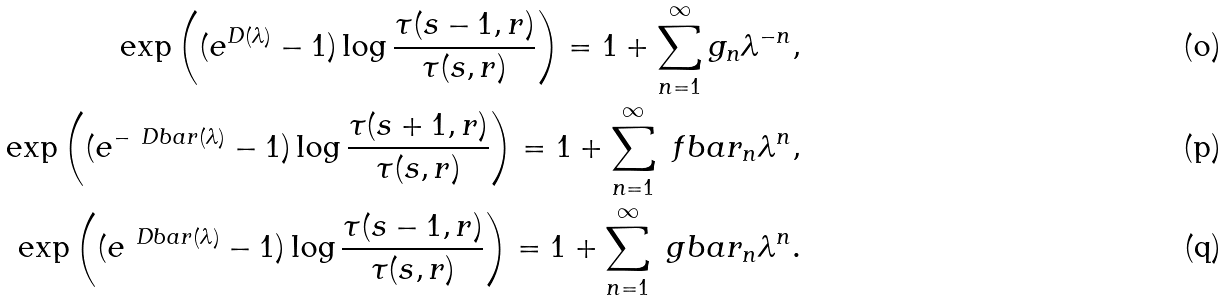<formula> <loc_0><loc_0><loc_500><loc_500>\exp \left ( ( e ^ { D ( \lambda ) } - 1 ) \log \frac { \tau ( s - 1 , r ) } { \tau ( s , r ) } \right ) = 1 + \sum _ { n = 1 } ^ { \infty } g _ { n } \lambda ^ { - n } , \\ \exp \left ( ( e ^ { - \ D b a r ( \lambda ) } - 1 ) \log \frac { \tau ( s + 1 , r ) } { \tau ( s , r ) } \right ) = 1 + \sum _ { n = 1 } ^ { \infty } \ f b a r _ { n } \lambda ^ { n } , \\ \exp \left ( ( e ^ { \ D b a r ( \lambda ) } - 1 ) \log \frac { \tau ( s - 1 , r ) } { \tau ( s , r ) } \right ) = 1 + \sum _ { n = 1 } ^ { \infty } \ g b a r _ { n } \lambda ^ { n } .</formula> 